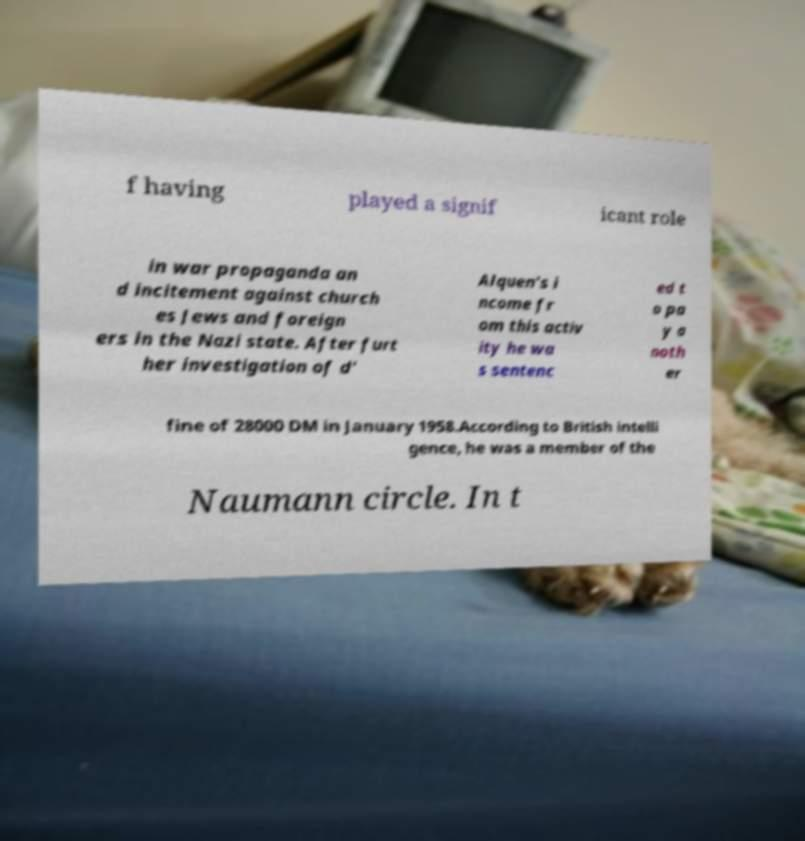Can you read and provide the text displayed in the image?This photo seems to have some interesting text. Can you extract and type it out for me? f having played a signif icant role in war propaganda an d incitement against church es Jews and foreign ers in the Nazi state. After furt her investigation of d' Alquen's i ncome fr om this activ ity he wa s sentenc ed t o pa y a noth er fine of 28000 DM in January 1958.According to British intelli gence, he was a member of the Naumann circle. In t 